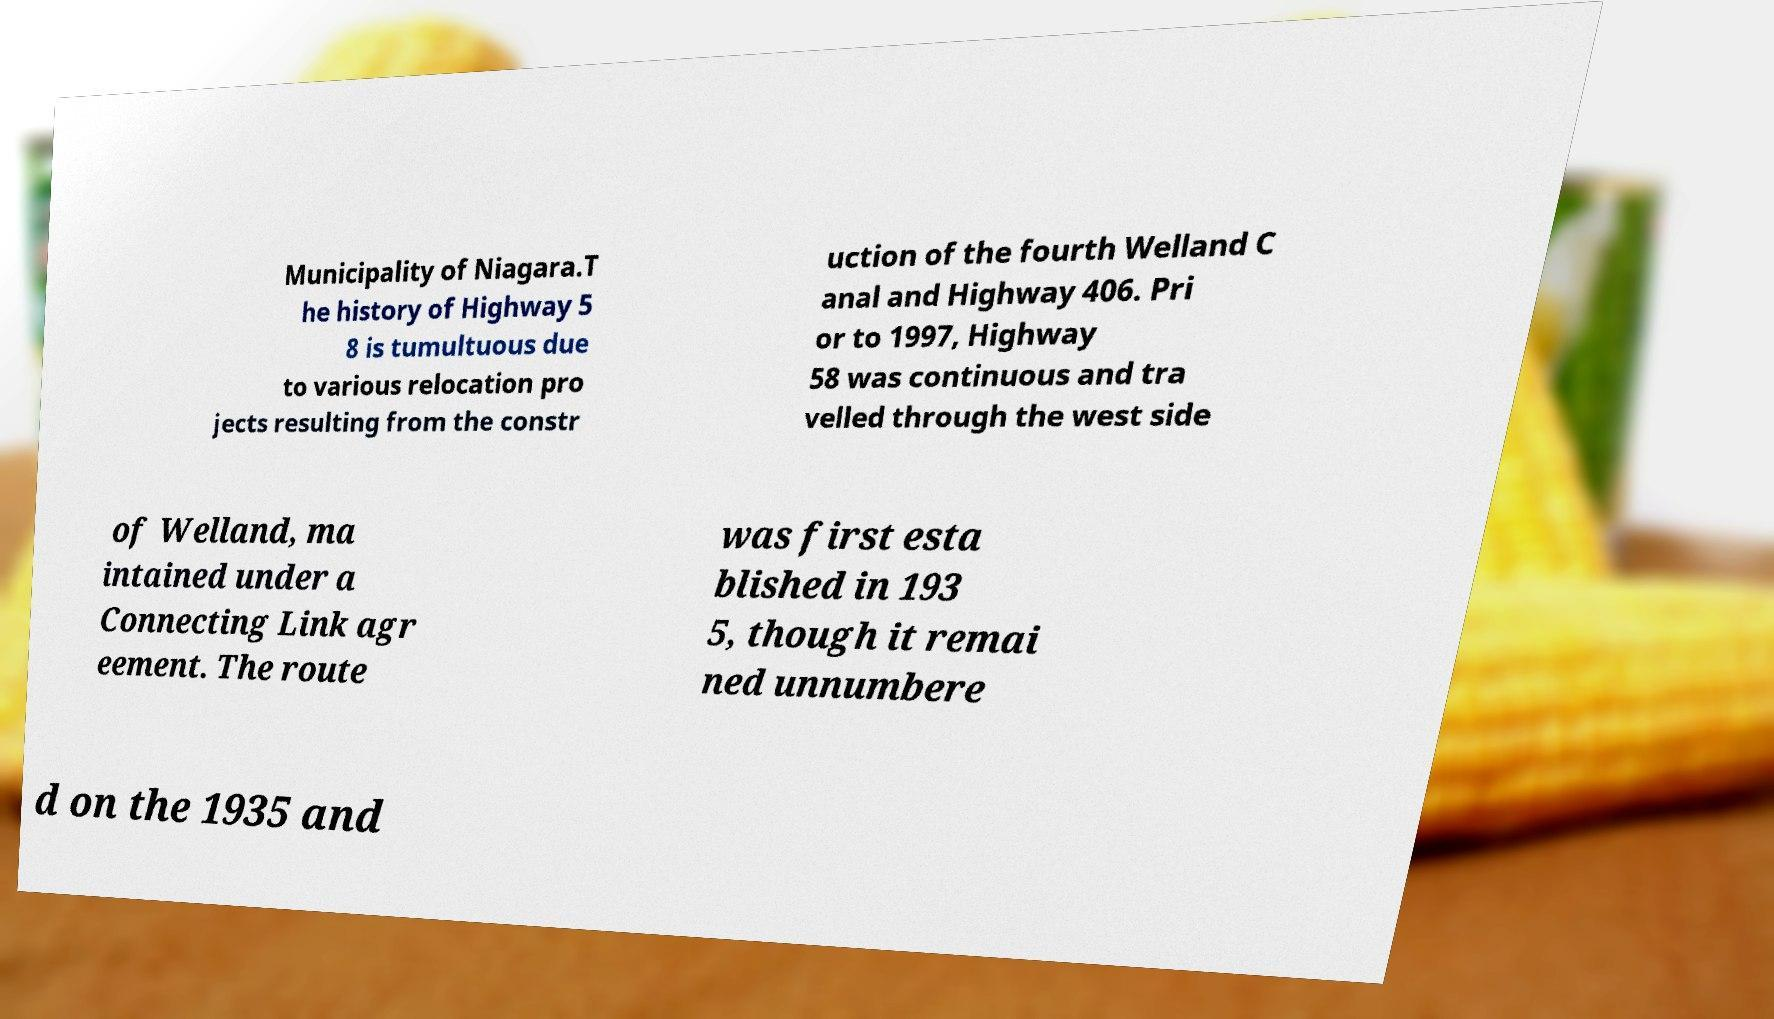Could you extract and type out the text from this image? Municipality of Niagara.T he history of Highway 5 8 is tumultuous due to various relocation pro jects resulting from the constr uction of the fourth Welland C anal and Highway 406. Pri or to 1997, Highway 58 was continuous and tra velled through the west side of Welland, ma intained under a Connecting Link agr eement. The route was first esta blished in 193 5, though it remai ned unnumbere d on the 1935 and 